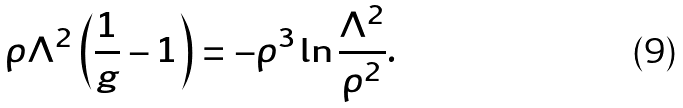<formula> <loc_0><loc_0><loc_500><loc_500>\rho \Lambda ^ { 2 } \left ( \frac { 1 } { g } - 1 \right ) = - \rho ^ { 3 } \ln \frac { \Lambda ^ { 2 } } { \rho ^ { 2 } } .</formula> 